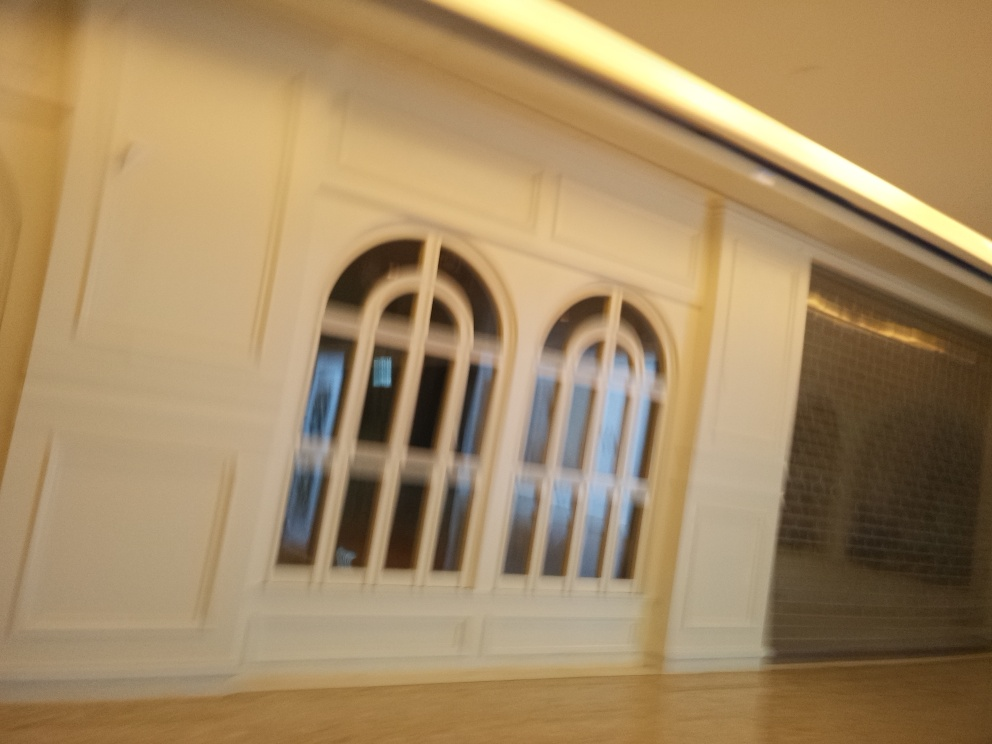Could you speculate on why this photo might have been taken? The photo may have been taken unintentionally, perhaps in a hurry or while in motion, resulting in the blur. Alternatively, it might have been a creative choice to convey a sense of movement or an abstract interpretation of the space. Or it could simply be an accidental snapshot by an amateur photographer getting acquainted with their camera settings. 